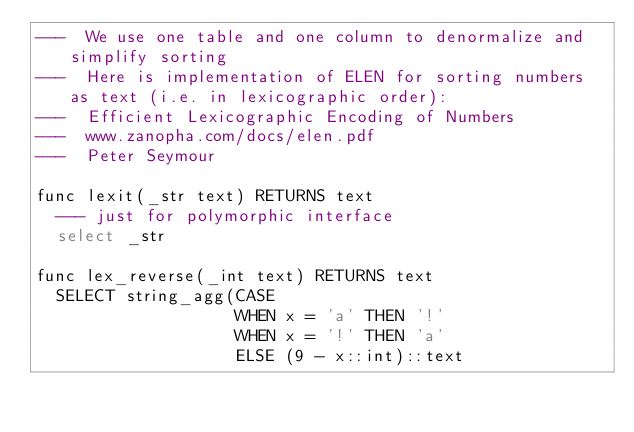Convert code to text. <code><loc_0><loc_0><loc_500><loc_500><_SQL_>---  We use one table and one column to denormalize and simplify sorting
---  Here is implementation of ELEN for sorting numbers as text (i.e. in lexicographic order):
---  Efficient Lexicographic Encoding of Numbers
---  www.zanopha.com/docs/elen.pdf
---  Peter Seymour

func lexit(_str text) RETURNS text
  --- just for polymorphic interface
  select _str

func lex_reverse(_int text) RETURNS text
  SELECT string_agg(CASE
                    WHEN x = 'a' THEN '!'
                    WHEN x = '!' THEN 'a'
                    ELSE (9 - x::int)::text</code> 